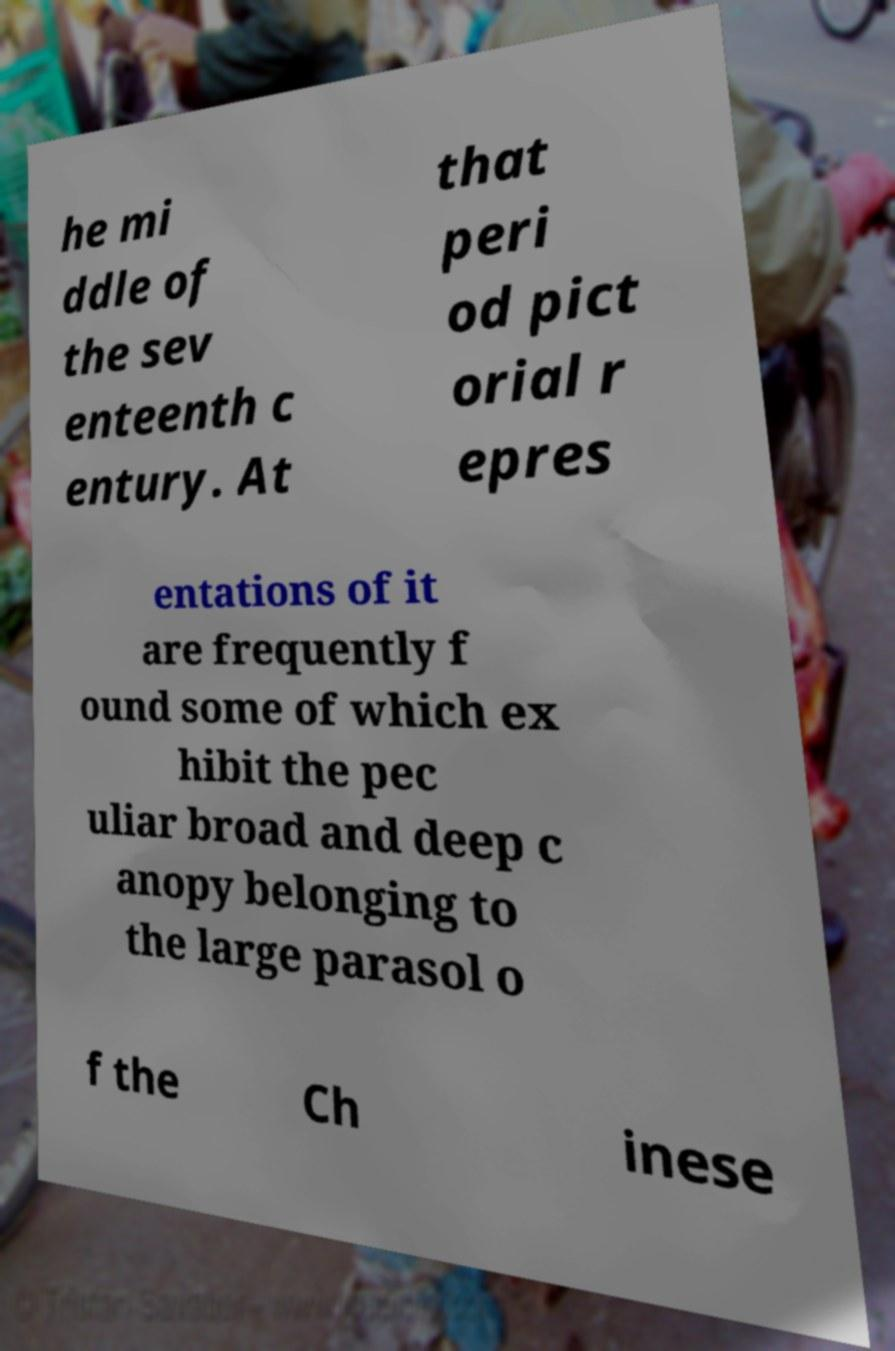Can you accurately transcribe the text from the provided image for me? he mi ddle of the sev enteenth c entury. At that peri od pict orial r epres entations of it are frequently f ound some of which ex hibit the pec uliar broad and deep c anopy belonging to the large parasol o f the Ch inese 